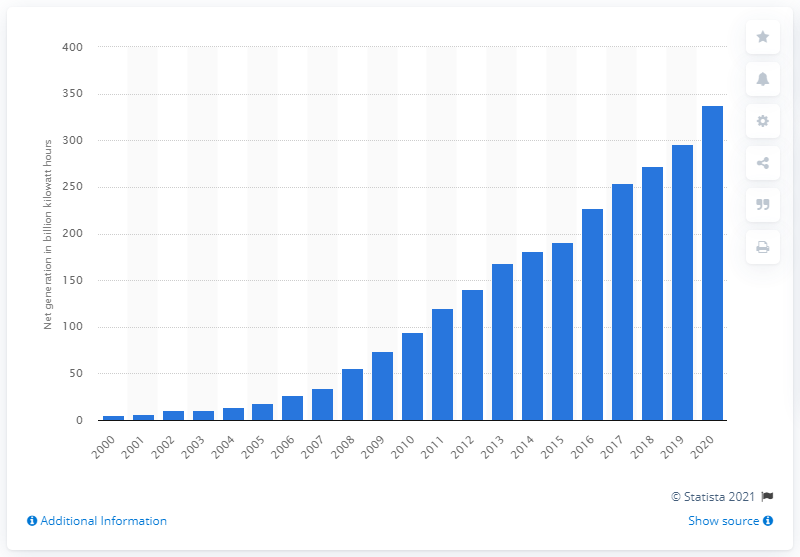Specify some key components in this picture. In 2020, a total of 337.51 gigawatt-hours of wind electricity was generated in the United States. 